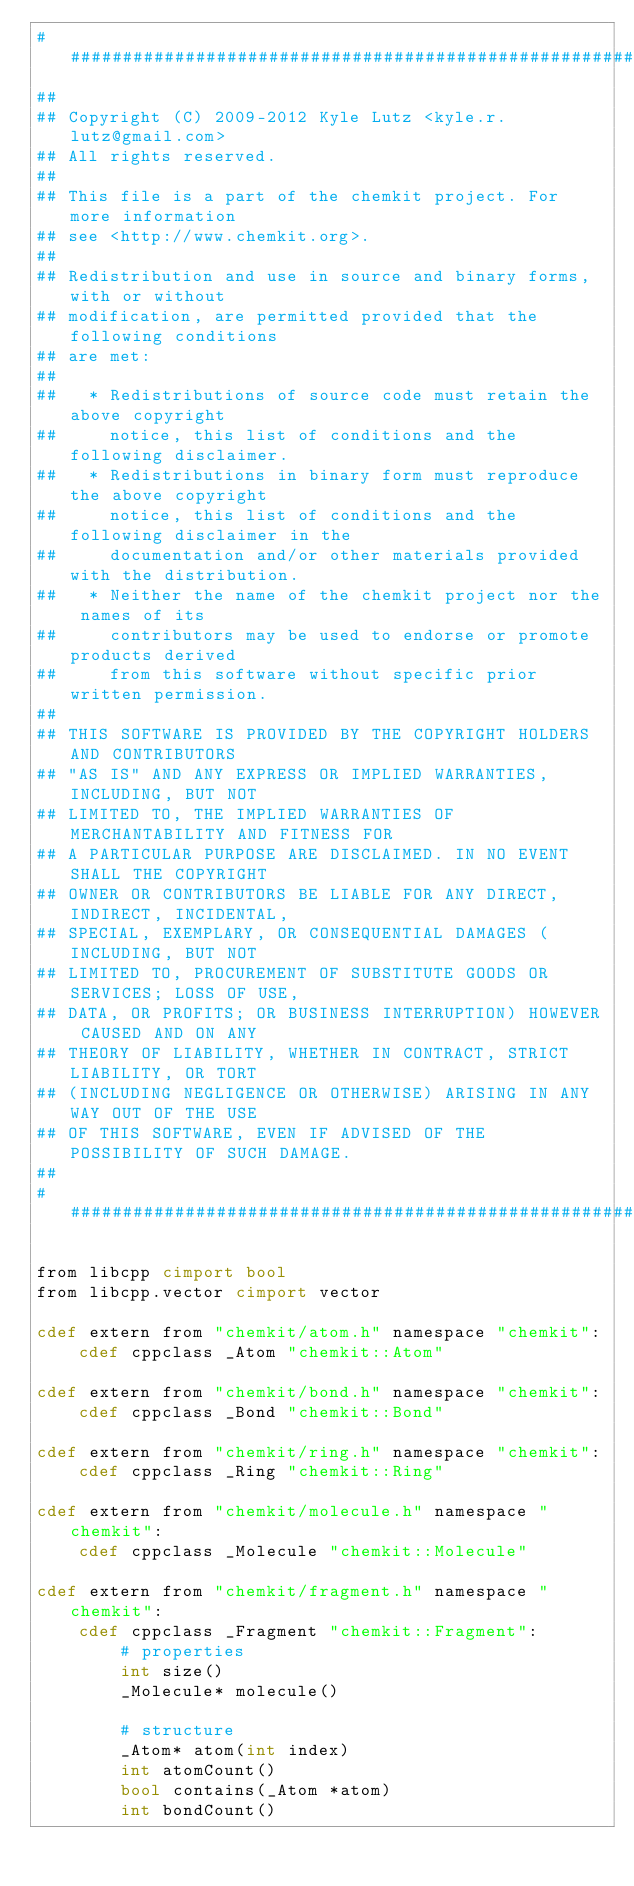Convert code to text. <code><loc_0><loc_0><loc_500><loc_500><_Cython_>###############################################################################
##
## Copyright (C) 2009-2012 Kyle Lutz <kyle.r.lutz@gmail.com>
## All rights reserved.
##
## This file is a part of the chemkit project. For more information
## see <http://www.chemkit.org>.
##
## Redistribution and use in source and binary forms, with or without
## modification, are permitted provided that the following conditions
## are met:
##
##   * Redistributions of source code must retain the above copyright
##     notice, this list of conditions and the following disclaimer.
##   * Redistributions in binary form must reproduce the above copyright
##     notice, this list of conditions and the following disclaimer in the
##     documentation and/or other materials provided with the distribution.
##   * Neither the name of the chemkit project nor the names of its
##     contributors may be used to endorse or promote products derived
##     from this software without specific prior written permission.
##
## THIS SOFTWARE IS PROVIDED BY THE COPYRIGHT HOLDERS AND CONTRIBUTORS
## "AS IS" AND ANY EXPRESS OR IMPLIED WARRANTIES, INCLUDING, BUT NOT
## LIMITED TO, THE IMPLIED WARRANTIES OF MERCHANTABILITY AND FITNESS FOR
## A PARTICULAR PURPOSE ARE DISCLAIMED. IN NO EVENT SHALL THE COPYRIGHT
## OWNER OR CONTRIBUTORS BE LIABLE FOR ANY DIRECT, INDIRECT, INCIDENTAL,
## SPECIAL, EXEMPLARY, OR CONSEQUENTIAL DAMAGES (INCLUDING, BUT NOT
## LIMITED TO, PROCUREMENT OF SUBSTITUTE GOODS OR SERVICES; LOSS OF USE,
## DATA, OR PROFITS; OR BUSINESS INTERRUPTION) HOWEVER CAUSED AND ON ANY
## THEORY OF LIABILITY, WHETHER IN CONTRACT, STRICT LIABILITY, OR TORT
## (INCLUDING NEGLIGENCE OR OTHERWISE) ARISING IN ANY WAY OUT OF THE USE
## OF THIS SOFTWARE, EVEN IF ADVISED OF THE POSSIBILITY OF SUCH DAMAGE.
##
###############################################################################

from libcpp cimport bool
from libcpp.vector cimport vector

cdef extern from "chemkit/atom.h" namespace "chemkit":
    cdef cppclass _Atom "chemkit::Atom"

cdef extern from "chemkit/bond.h" namespace "chemkit":
    cdef cppclass _Bond "chemkit::Bond"

cdef extern from "chemkit/ring.h" namespace "chemkit":
    cdef cppclass _Ring "chemkit::Ring"

cdef extern from "chemkit/molecule.h" namespace "chemkit":
    cdef cppclass _Molecule "chemkit::Molecule"

cdef extern from "chemkit/fragment.h" namespace "chemkit":
    cdef cppclass _Fragment "chemkit::Fragment":
        # properties
        int size()
        _Molecule* molecule()

        # structure
        _Atom* atom(int index)
        int atomCount()
        bool contains(_Atom *atom)
        int bondCount()

</code> 